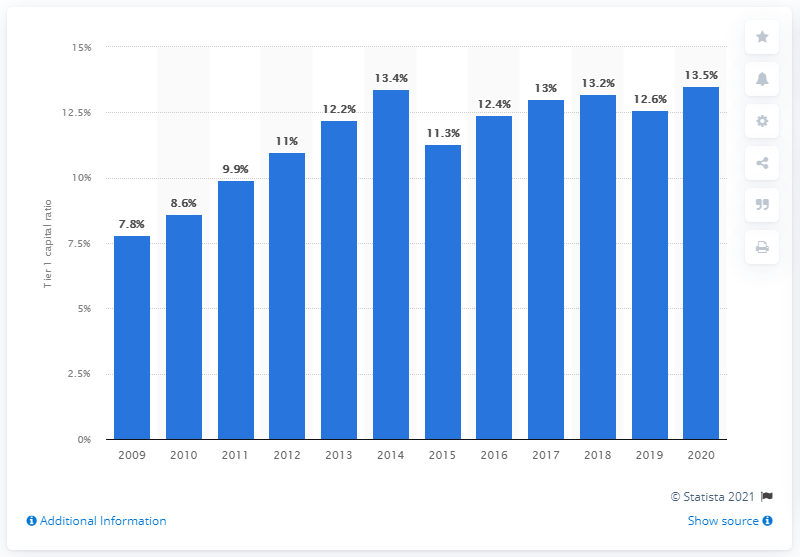Indicate a few pertinent items in this graphic. The Bank of America's tier 1 common capital ratio in 2020 was 13.5%. 